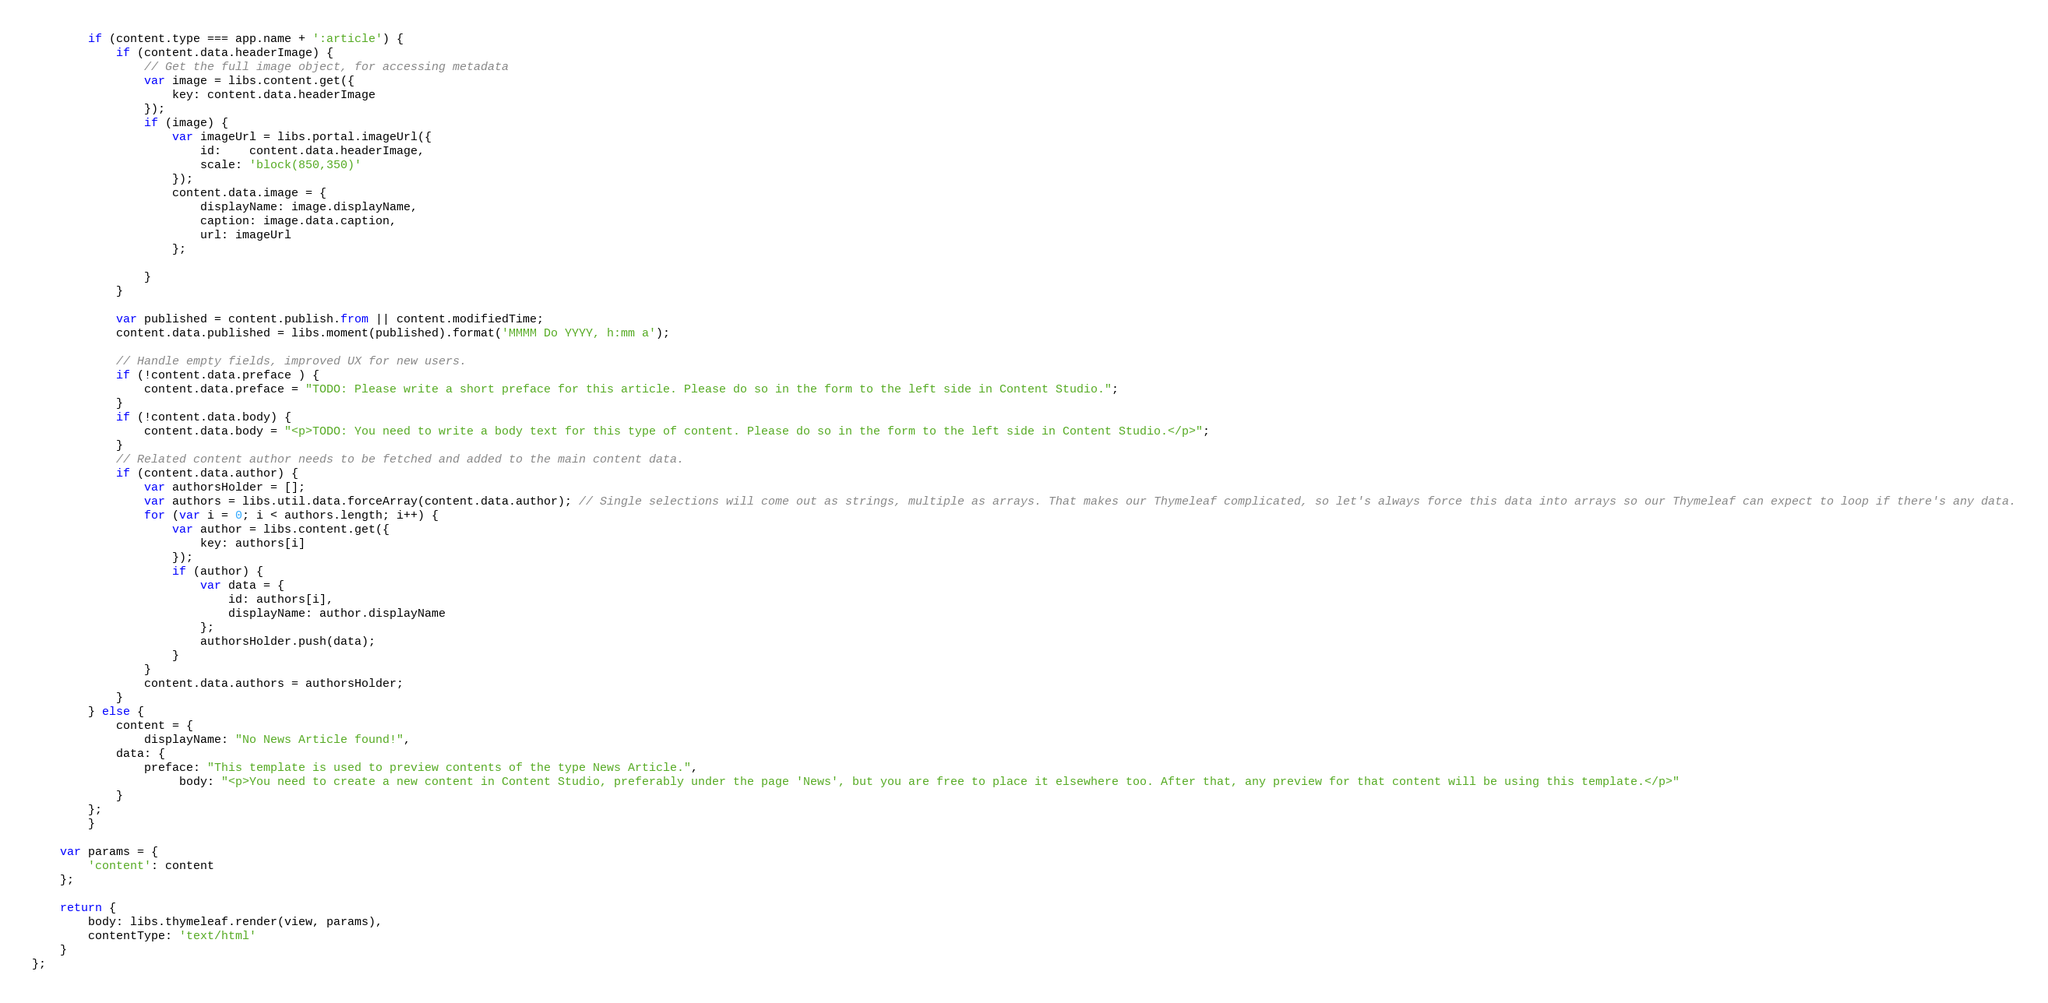Convert code to text. <code><loc_0><loc_0><loc_500><loc_500><_JavaScript_>		if (content.type === app.name + ':article') {
			if (content.data.headerImage) {
				// Get the full image object, for accessing metadata
				var image = libs.content.get({
					key: content.data.headerImage
				});
				if (image) {
					var imageUrl = libs.portal.imageUrl({
						id:    content.data.headerImage,
						scale: 'block(850,350)'
					});
					content.data.image = {
						displayName: image.displayName,
						caption: image.data.caption,
						url: imageUrl
					};

				}
			}

			var published = content.publish.from || content.modifiedTime;
			content.data.published = libs.moment(published).format('MMMM Do YYYY, h:mm a');

			// Handle empty fields, improved UX for new users.
			if (!content.data.preface ) {
				content.data.preface = "TODO: Please write a short preface for this article. Please do so in the form to the left side in Content Studio.";
			}
			if (!content.data.body) {
				content.data.body = "<p>TODO: You need to write a body text for this type of content. Please do so in the form to the left side in Content Studio.</p>";
			}
			// Related content author needs to be fetched and added to the main content data.
			if (content.data.author) {
				var authorsHolder = [];
				var authors = libs.util.data.forceArray(content.data.author); // Single selections will come out as strings, multiple as arrays. That makes our Thymeleaf complicated, so let's always force this data into arrays so our Thymeleaf can expect to loop if there's any data.
				for (var i = 0; i < authors.length; i++) {
					var author = libs.content.get({
						key: authors[i]
					});
					if (author) {
						var data = {
							id: authors[i],
							displayName: author.displayName
						};
						authorsHolder.push(data);
					}
				}
				content.data.authors = authorsHolder;
			}
		} else {
			content = {
				displayName: "No News Article found!",
            data: {
                preface: "This template is used to preview contents of the type News Article.",
					 body: "<p>You need to create a new content in Content Studio, preferably under the page 'News', but you are free to place it elsewhere too. After that, any preview for that content will be using this template.</p>"
            }
        };
		}

    var params = {
        'content': content
    };

    return {
        body: libs.thymeleaf.render(view, params),
        contentType: 'text/html'
    }
};
</code> 